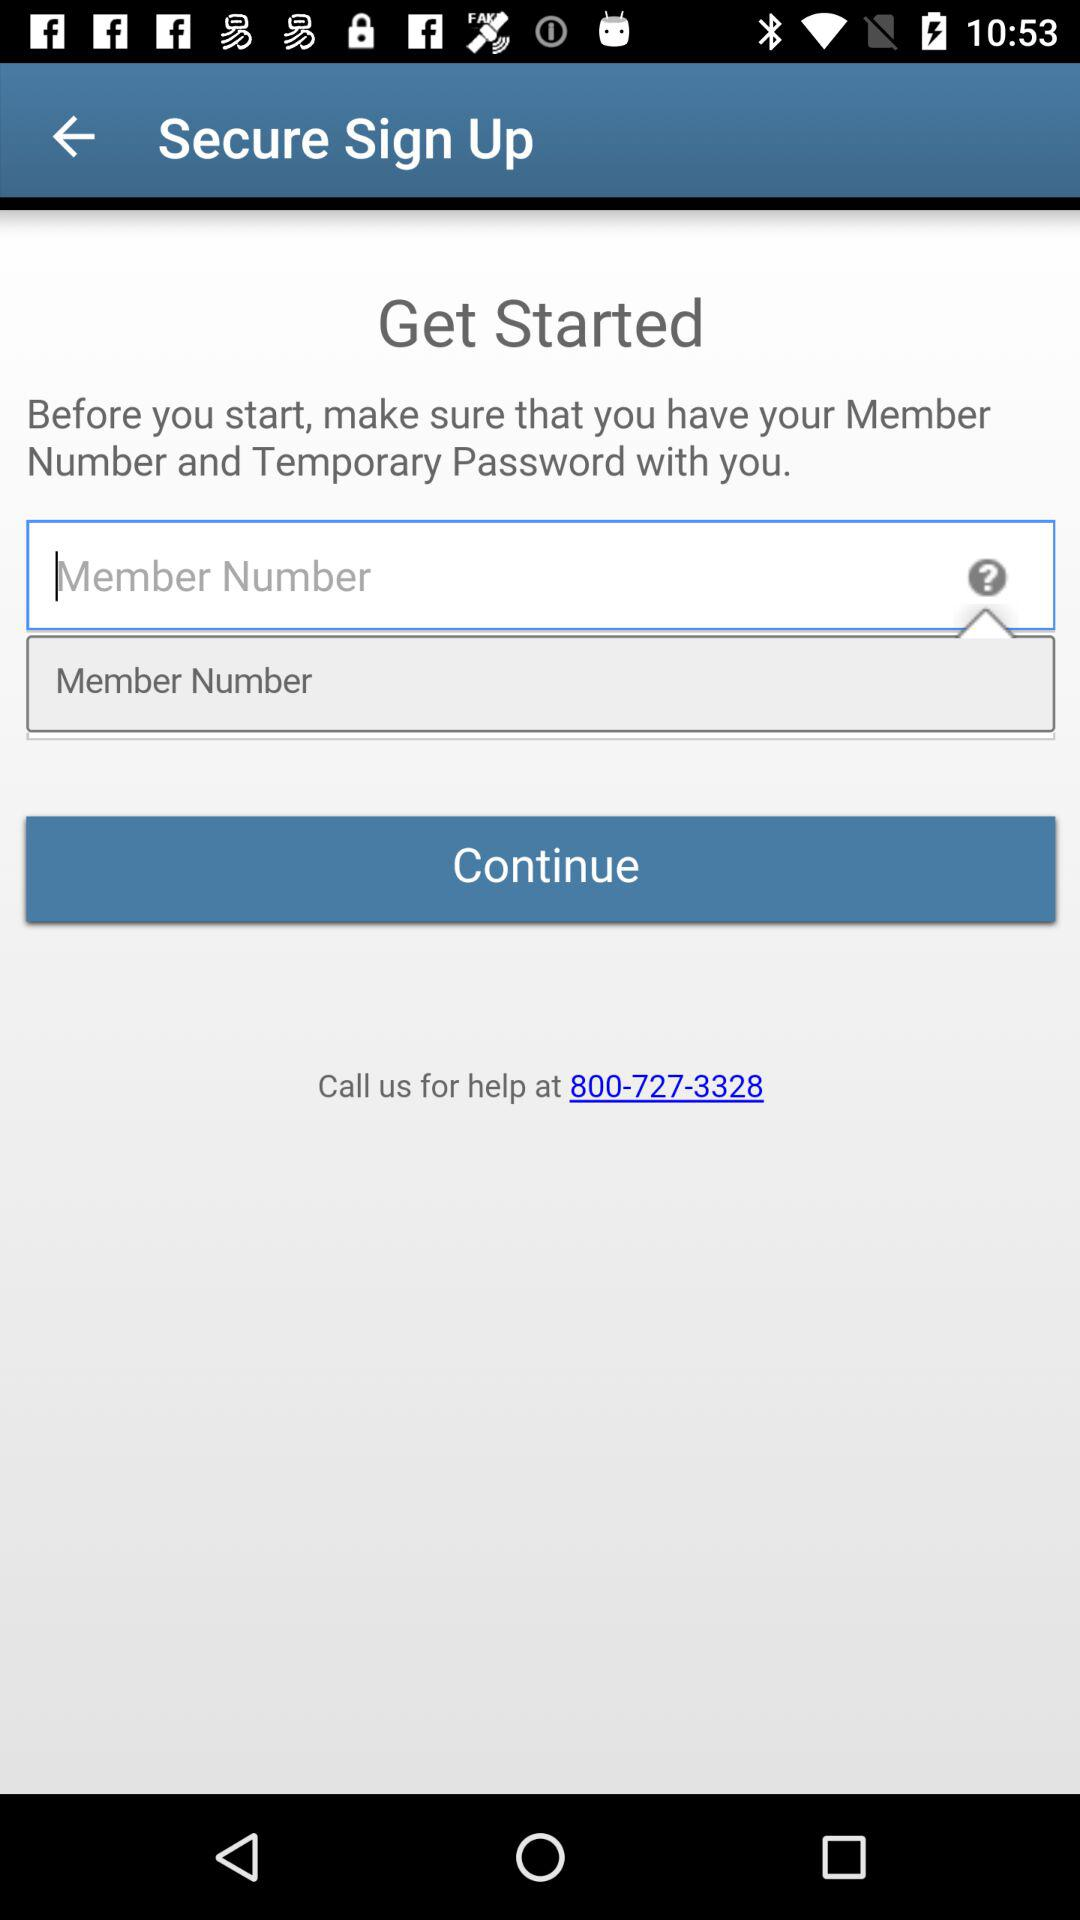What is the contact number? The contact number is 800-727-3328. 